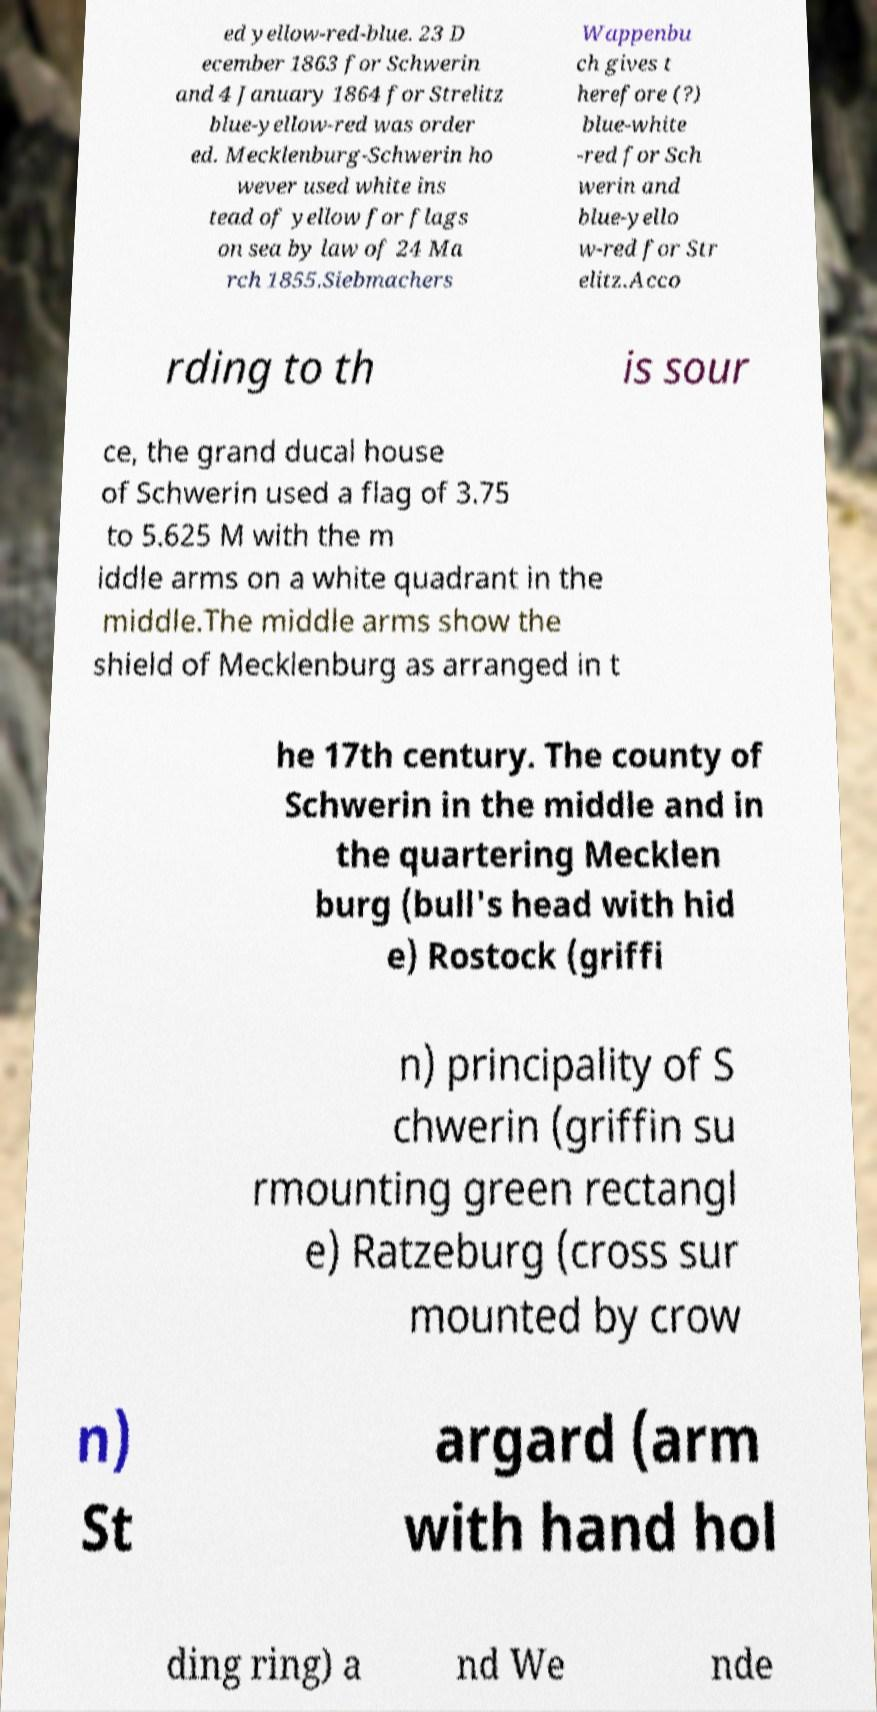For documentation purposes, I need the text within this image transcribed. Could you provide that? ed yellow-red-blue. 23 D ecember 1863 for Schwerin and 4 January 1864 for Strelitz blue-yellow-red was order ed. Mecklenburg-Schwerin ho wever used white ins tead of yellow for flags on sea by law of 24 Ma rch 1855.Siebmachers Wappenbu ch gives t herefore (?) blue-white -red for Sch werin and blue-yello w-red for Str elitz.Acco rding to th is sour ce, the grand ducal house of Schwerin used a flag of 3.75 to 5.625 M with the m iddle arms on a white quadrant in the middle.The middle arms show the shield of Mecklenburg as arranged in t he 17th century. The county of Schwerin in the middle and in the quartering Mecklen burg (bull's head with hid e) Rostock (griffi n) principality of S chwerin (griffin su rmounting green rectangl e) Ratzeburg (cross sur mounted by crow n) St argard (arm with hand hol ding ring) a nd We nde 